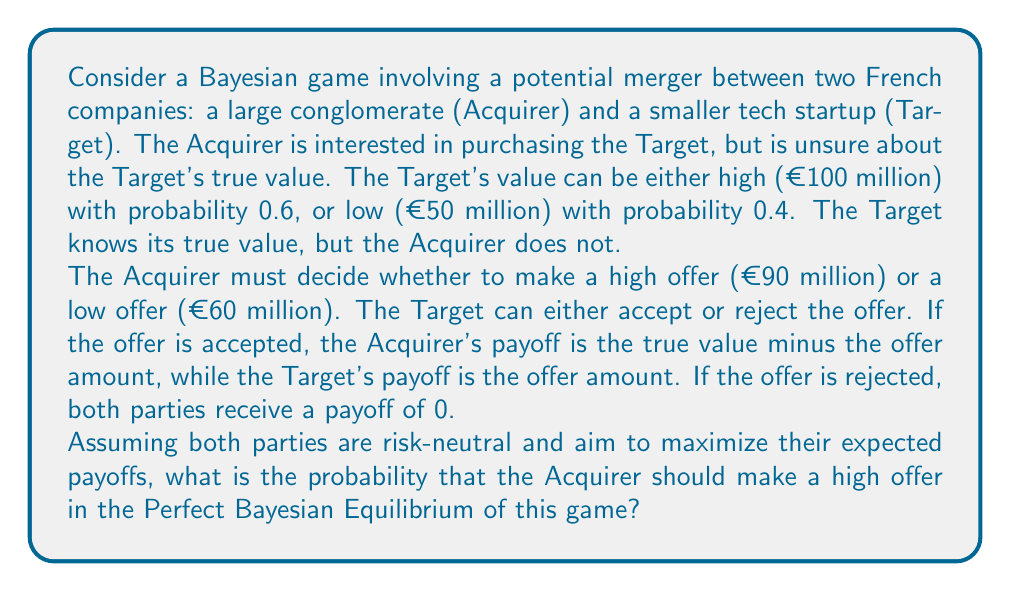Teach me how to tackle this problem. To solve this Bayesian game, we need to find the Perfect Bayesian Equilibrium (PBE). Let's approach this step-by-step:

1) First, let's define the strategies:
   - Acquirer: $p$ = probability of making a high offer
   - High-value Target: $q_H$ = probability of accepting a low offer
   - Low-value Target: $q_L$ = probability of accepting a low offer

2) For the Target:
   - High-value Target will always accept a high offer and reject a low offer, so $q_H = 0$
   - Low-value Target will always accept either offer, so $q_L = 1$

3) For the Acquirer, we need to calculate the expected payoff of each action:

   High offer (€90 million):
   $E[\text{High offer}] = 0.6(100-90) + 0.4(50-90) = 6 - 16 = -10$ million

   Low offer (€60 million):
   $E[\text{Low offer}] = 0.6(0) + 0.4(50-60) = -4$ million

4) In equilibrium, the Acquirer should be indifferent between high and low offers:

   $-10p + (-4)(1-p) = -4$
   $-10p - 4 + 4p = -4$
   $-6p = 0$
   $p = 0$

5) This means that in the PBE, the Acquirer should always make a low offer.

However, this solution doesn't seem intuitive given the probabilities and payoffs. Let's verify by checking the Acquirer's best response to the Target's strategy:

If the Acquirer makes a high offer, the expected payoff is -10 million.
If the Acquirer makes a low offer, only the low-value Target accepts, so the expected payoff is:

$0.4(50-60) = -4$ million

Indeed, the low offer yields a higher expected payoff (-4 > -10), confirming our solution.
Answer: The probability that the Acquirer should make a high offer in the Perfect Bayesian Equilibrium is $p = 0$, or 0%. 